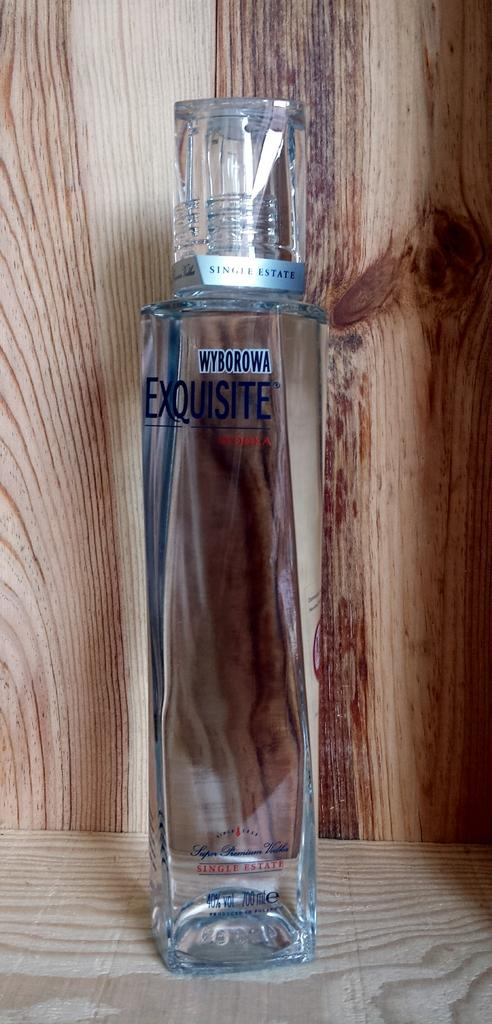<image>
Give a short and clear explanation of the subsequent image. A jewel cut bottle of Exquisite brand vodka. 